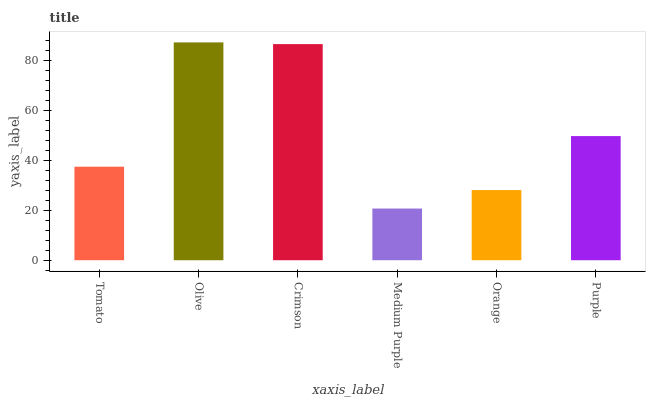Is Medium Purple the minimum?
Answer yes or no. Yes. Is Olive the maximum?
Answer yes or no. Yes. Is Crimson the minimum?
Answer yes or no. No. Is Crimson the maximum?
Answer yes or no. No. Is Olive greater than Crimson?
Answer yes or no. Yes. Is Crimson less than Olive?
Answer yes or no. Yes. Is Crimson greater than Olive?
Answer yes or no. No. Is Olive less than Crimson?
Answer yes or no. No. Is Purple the high median?
Answer yes or no. Yes. Is Tomato the low median?
Answer yes or no. Yes. Is Tomato the high median?
Answer yes or no. No. Is Purple the low median?
Answer yes or no. No. 